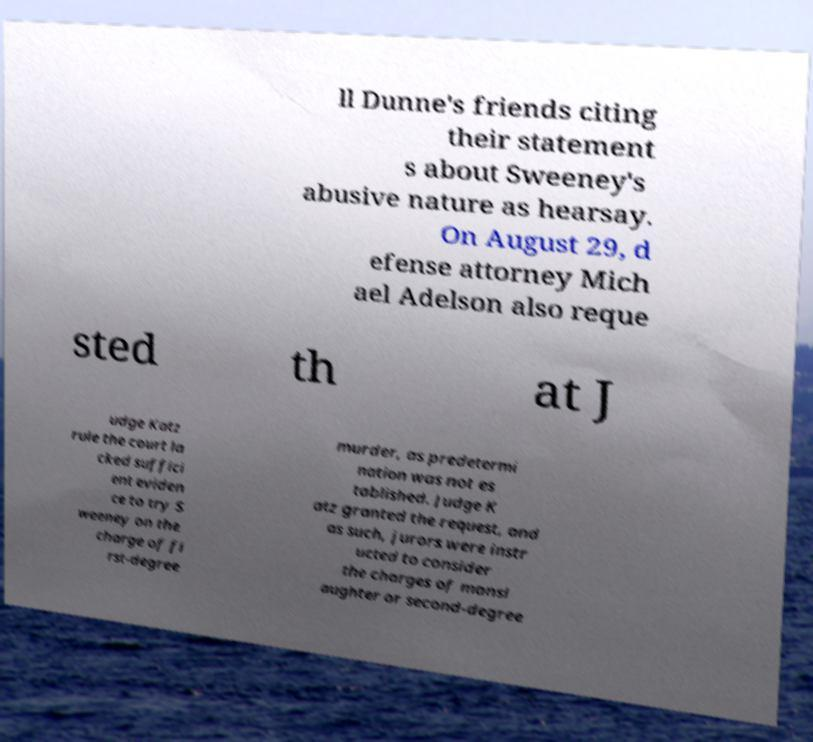Please read and relay the text visible in this image. What does it say? ll Dunne's friends citing their statement s about Sweeney's abusive nature as hearsay. On August 29, d efense attorney Mich ael Adelson also reque sted th at J udge Katz rule the court la cked suffici ent eviden ce to try S weeney on the charge of fi rst-degree murder, as predetermi nation was not es tablished. Judge K atz granted the request, and as such, jurors were instr ucted to consider the charges of mansl aughter or second-degree 